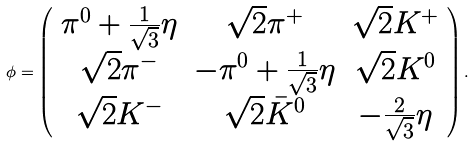<formula> <loc_0><loc_0><loc_500><loc_500>\phi = \left ( \begin{array} { c c c } \pi ^ { 0 } + \frac { 1 } { \sqrt { 3 } } \eta & \sqrt { 2 } \pi ^ { + } & \sqrt { 2 } K ^ { + } \\ \sqrt { 2 } \pi ^ { - } & - \pi ^ { 0 } + \frac { 1 } { \sqrt { 3 } } \eta & \sqrt { 2 } K ^ { 0 } \\ \sqrt { 2 } K ^ { - } & \sqrt { 2 } \bar { K } ^ { 0 } & - \frac { 2 } { \sqrt { 3 } } \eta \end{array} \right ) .</formula> 